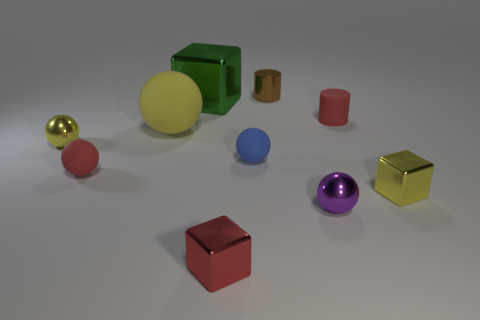What colors are present besides red and gray in the image? Besides red and gray, there are objects of yellow, green, blue, purple, gold, and a neutral cream color in the image. 